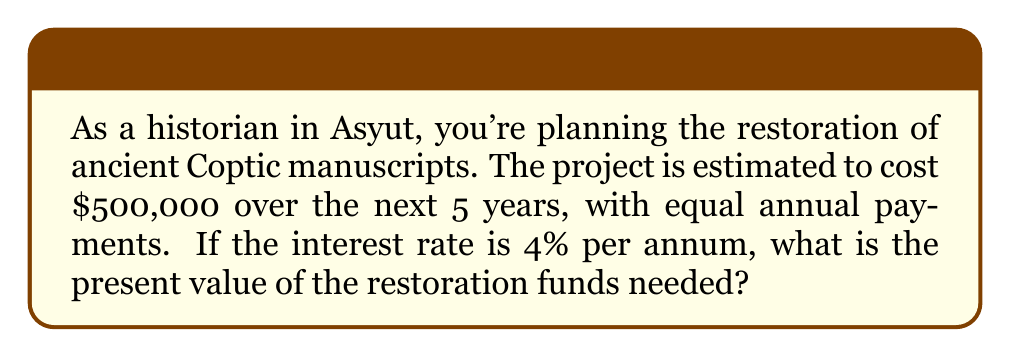Can you answer this question? To solve this problem, we need to calculate the present value of an annuity. The formula for the present value of an annuity is:

$$PV = PMT \cdot \frac{1 - (1 + r)^{-n}}{r}$$

Where:
$PV$ = Present Value
$PMT$ = Payment amount per period
$r$ = Interest rate per period
$n$ = Number of periods

Given:
- Total cost = $500,000
- Number of years = 5
- Interest rate = 4% = 0.04
- Equal annual payments

Step 1: Calculate the annual payment amount
$$PMT = \frac{500,000}{5} = 100,000$$

Step 2: Apply the formula
$$PV = 100,000 \cdot \frac{1 - (1 + 0.04)^{-5}}{0.04}$$

Step 3: Calculate $(1 + 0.04)^{-5}$
$$(1 + 0.04)^{-5} = 0.8219271$$

Step 4: Substitute and solve
$$PV = 100,000 \cdot \frac{1 - 0.8219271}{0.04} = 100,000 \cdot 4.4518242 = 445,182.42$$

Therefore, the present value of the restoration funds needed is $445,182.42.
Answer: $445,182.42 